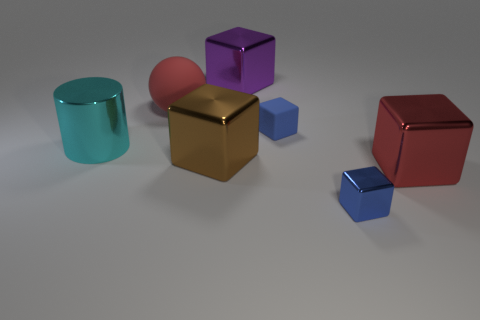How many metal things are either green spheres or cubes?
Provide a short and direct response. 4. Is the block behind the large red sphere made of the same material as the blue block on the left side of the tiny metal thing?
Keep it short and to the point. No. What is the color of the small block that is the same material as the purple thing?
Offer a very short reply. Blue. Is the number of brown metal cubes behind the purple object greater than the number of big cylinders to the right of the big brown metallic block?
Give a very brief answer. No. Are there any large metallic cubes?
Your answer should be very brief. Yes. What is the material of the big block that is the same color as the big matte object?
Your response must be concise. Metal. What number of things are big brown objects or small blue matte things?
Keep it short and to the point. 2. Are there any big cubes that have the same color as the sphere?
Your answer should be compact. Yes. There is a tiny thing that is in front of the large cyan metallic cylinder; how many metal objects are on the right side of it?
Your answer should be compact. 1. Is the number of objects greater than the number of small metal objects?
Your response must be concise. Yes. 